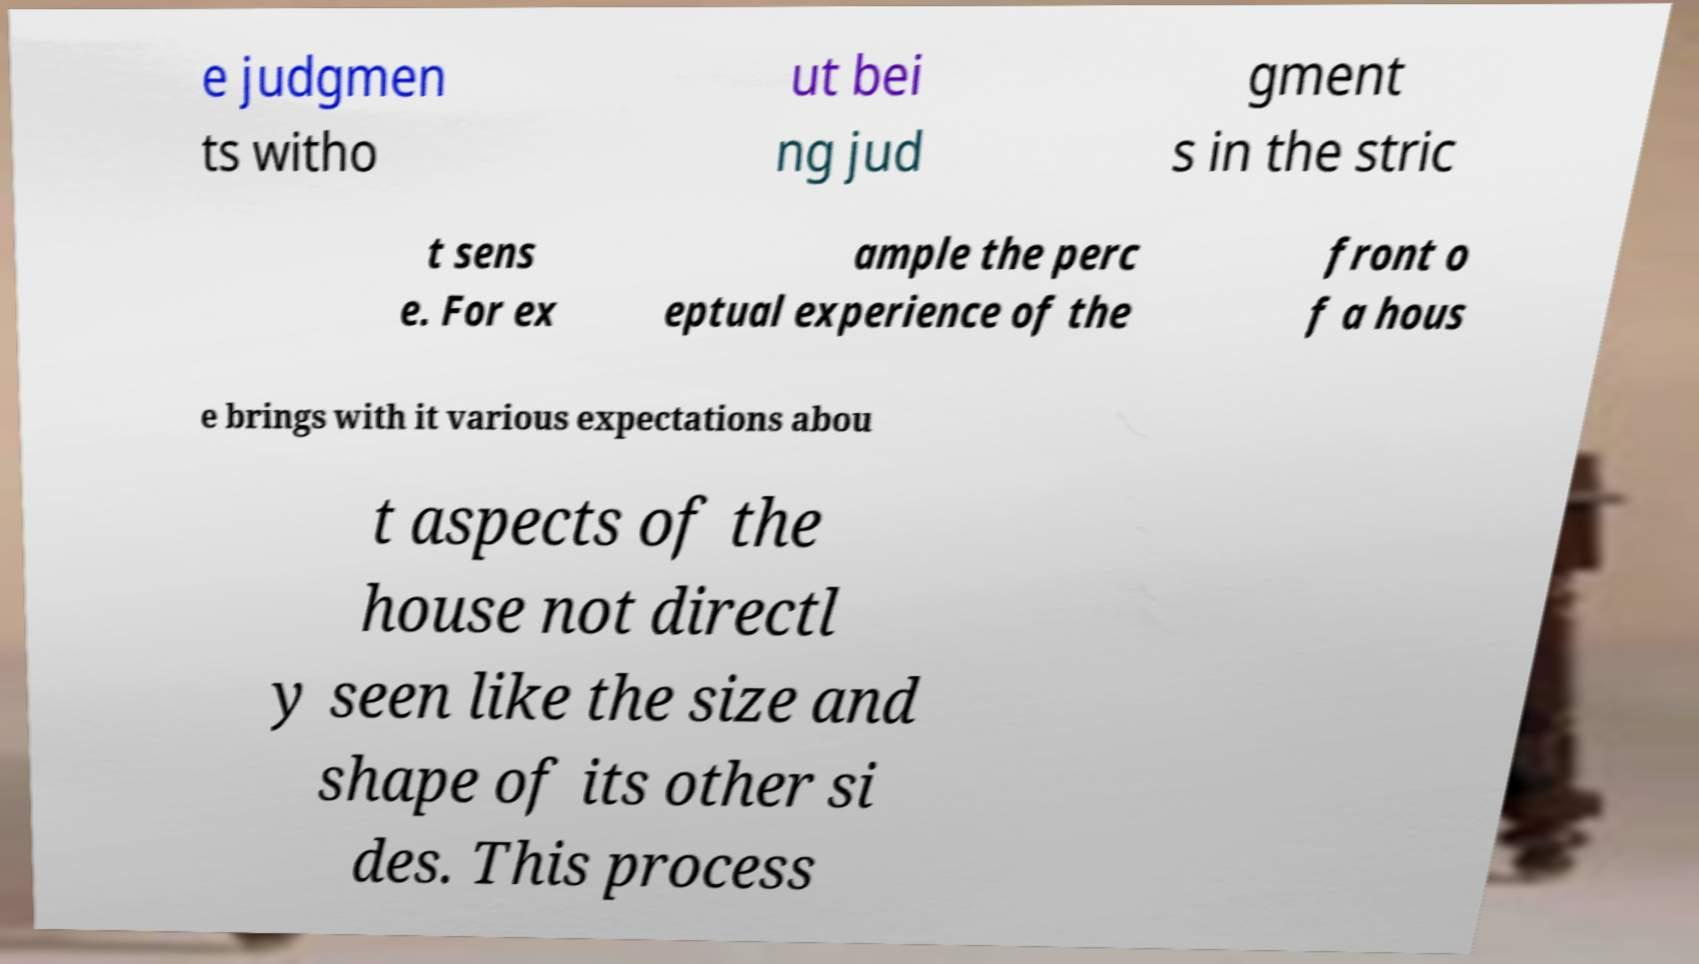There's text embedded in this image that I need extracted. Can you transcribe it verbatim? e judgmen ts witho ut bei ng jud gment s in the stric t sens e. For ex ample the perc eptual experience of the front o f a hous e brings with it various expectations abou t aspects of the house not directl y seen like the size and shape of its other si des. This process 